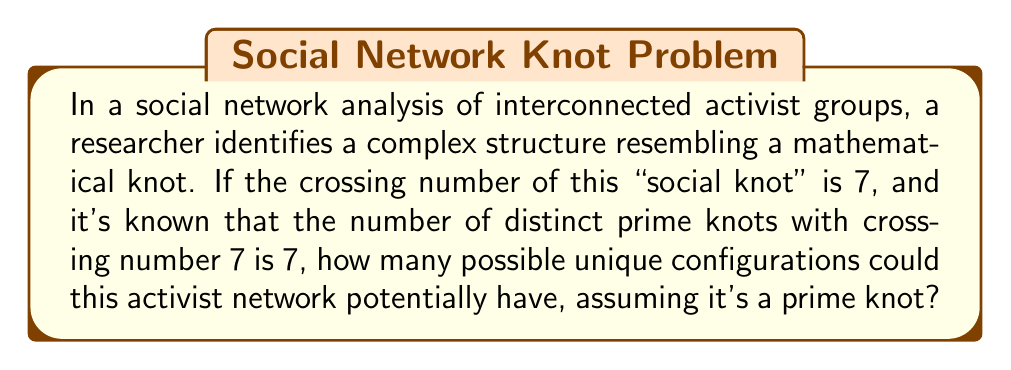Can you solve this math problem? To solve this problem, we need to understand a few key concepts from knot theory and their application to social network analysis:

1. Crossing number: In knot theory, the crossing number is the smallest number of crossings in any diagram of a knot. In our social network context, this represents the minimum number of intersections between different activist group connections.

2. Prime knots: A knot is considered prime if it cannot be decomposed into simpler knots. In social networks, this could represent a cohesive activist structure that cannot be separated into independent subgroups without breaking connections.

3. Distinct prime knots: This refers to the number of fundamentally different prime knot structures with a given crossing number. In our social context, these represent unique, indivisible network configurations.

Given:
- The crossing number of the "social knot" is 7.
- There are 7 distinct prime knots with crossing number 7.

In knot theory, this information is represented by the notation:

$$\text{Number of prime knots}(7) = 7$$

Since we're told that the activist network resembles a mathematical knot and we're assuming it's a prime knot, each of these 7 distinct prime knots represents a possible unique configuration for the activist network.

Therefore, the number of possible unique configurations for this activist network is equal to the number of distinct prime knots with crossing number 7, which is 7.
Answer: 7 